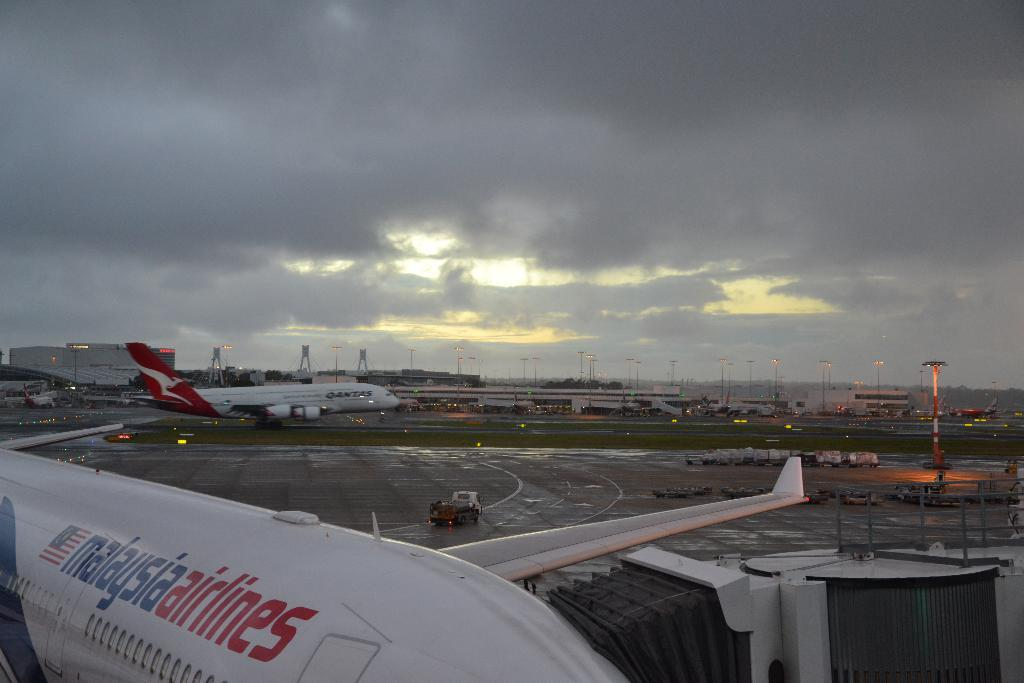<image>
Present a compact description of the photo's key features. Malaysia Airlines on a white plane and a Qantas plane in the back. 